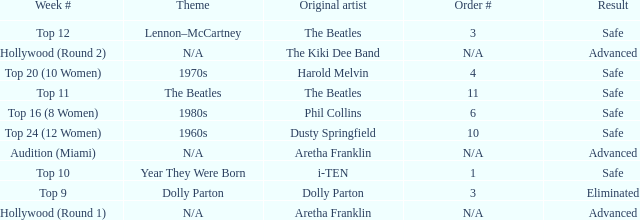What is the week number with Phil Collins as the original artist? Top 16 (8 Women). 